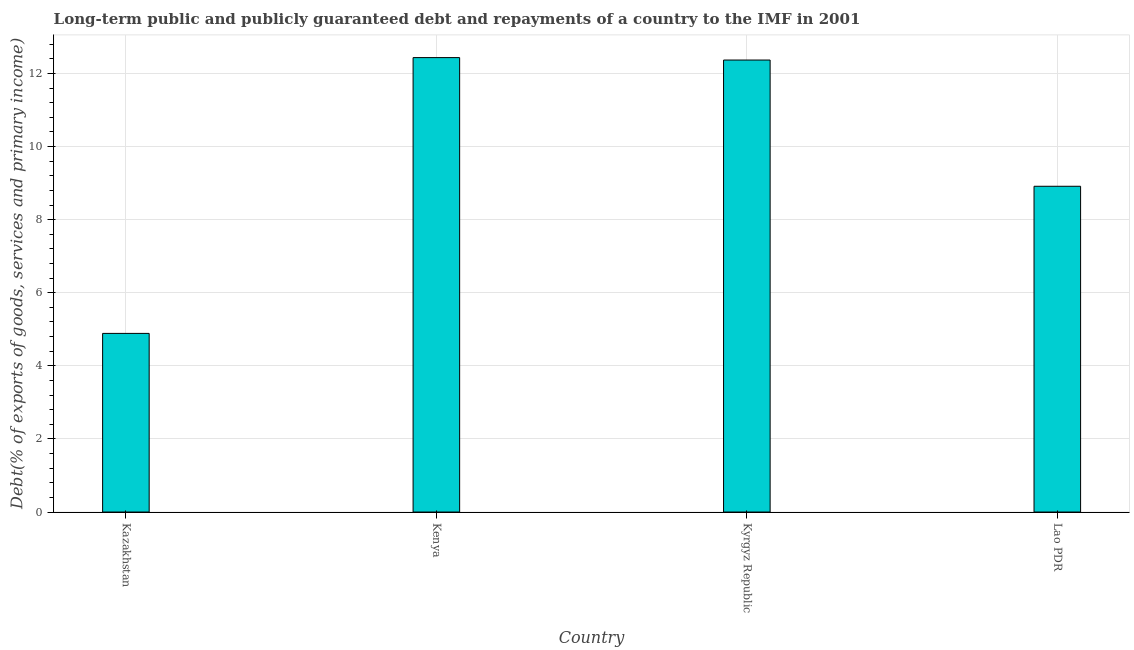Does the graph contain grids?
Provide a short and direct response. Yes. What is the title of the graph?
Offer a very short reply. Long-term public and publicly guaranteed debt and repayments of a country to the IMF in 2001. What is the label or title of the Y-axis?
Make the answer very short. Debt(% of exports of goods, services and primary income). What is the debt service in Lao PDR?
Your answer should be very brief. 8.91. Across all countries, what is the maximum debt service?
Keep it short and to the point. 12.43. Across all countries, what is the minimum debt service?
Your answer should be compact. 4.89. In which country was the debt service maximum?
Give a very brief answer. Kenya. In which country was the debt service minimum?
Keep it short and to the point. Kazakhstan. What is the sum of the debt service?
Your response must be concise. 38.6. What is the difference between the debt service in Kazakhstan and Kyrgyz Republic?
Your answer should be very brief. -7.48. What is the average debt service per country?
Provide a succinct answer. 9.65. What is the median debt service?
Provide a short and direct response. 10.64. What is the ratio of the debt service in Kazakhstan to that in Lao PDR?
Provide a short and direct response. 0.55. What is the difference between the highest and the second highest debt service?
Give a very brief answer. 0.07. What is the difference between the highest and the lowest debt service?
Ensure brevity in your answer.  7.55. How many bars are there?
Provide a short and direct response. 4. Are all the bars in the graph horizontal?
Your answer should be compact. No. How many countries are there in the graph?
Provide a short and direct response. 4. What is the difference between two consecutive major ticks on the Y-axis?
Give a very brief answer. 2. What is the Debt(% of exports of goods, services and primary income) in Kazakhstan?
Offer a terse response. 4.89. What is the Debt(% of exports of goods, services and primary income) of Kenya?
Give a very brief answer. 12.43. What is the Debt(% of exports of goods, services and primary income) in Kyrgyz Republic?
Make the answer very short. 12.37. What is the Debt(% of exports of goods, services and primary income) in Lao PDR?
Your answer should be compact. 8.91. What is the difference between the Debt(% of exports of goods, services and primary income) in Kazakhstan and Kenya?
Provide a succinct answer. -7.55. What is the difference between the Debt(% of exports of goods, services and primary income) in Kazakhstan and Kyrgyz Republic?
Make the answer very short. -7.48. What is the difference between the Debt(% of exports of goods, services and primary income) in Kazakhstan and Lao PDR?
Give a very brief answer. -4.03. What is the difference between the Debt(% of exports of goods, services and primary income) in Kenya and Kyrgyz Republic?
Your answer should be compact. 0.07. What is the difference between the Debt(% of exports of goods, services and primary income) in Kenya and Lao PDR?
Ensure brevity in your answer.  3.52. What is the difference between the Debt(% of exports of goods, services and primary income) in Kyrgyz Republic and Lao PDR?
Make the answer very short. 3.45. What is the ratio of the Debt(% of exports of goods, services and primary income) in Kazakhstan to that in Kenya?
Keep it short and to the point. 0.39. What is the ratio of the Debt(% of exports of goods, services and primary income) in Kazakhstan to that in Kyrgyz Republic?
Your response must be concise. 0.4. What is the ratio of the Debt(% of exports of goods, services and primary income) in Kazakhstan to that in Lao PDR?
Ensure brevity in your answer.  0.55. What is the ratio of the Debt(% of exports of goods, services and primary income) in Kenya to that in Lao PDR?
Your answer should be very brief. 1.4. What is the ratio of the Debt(% of exports of goods, services and primary income) in Kyrgyz Republic to that in Lao PDR?
Ensure brevity in your answer.  1.39. 